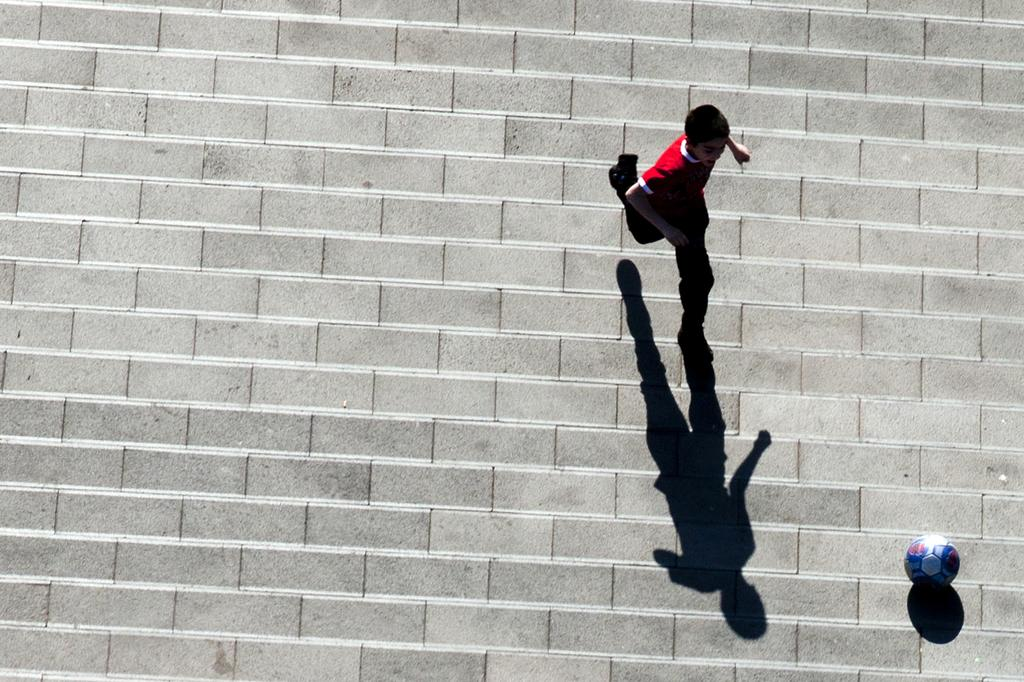What perspective is used in the image? The image is a top view. Who or what can be seen in the image? There is a child in the image. What is the child wearing? The child is wearing a red dress. What is the child doing in the image? The child is running on the ground. What other object is present in the image? There is a ball in the image. What can be observed about the child's shadow in the image? The shadow of the child is visible in the image. What is the name of the child in the image? The provided facts do not mention the name of the child, so we cannot determine their name from the image. How many eggs are visible in the image? There are no eggs present in the image. 